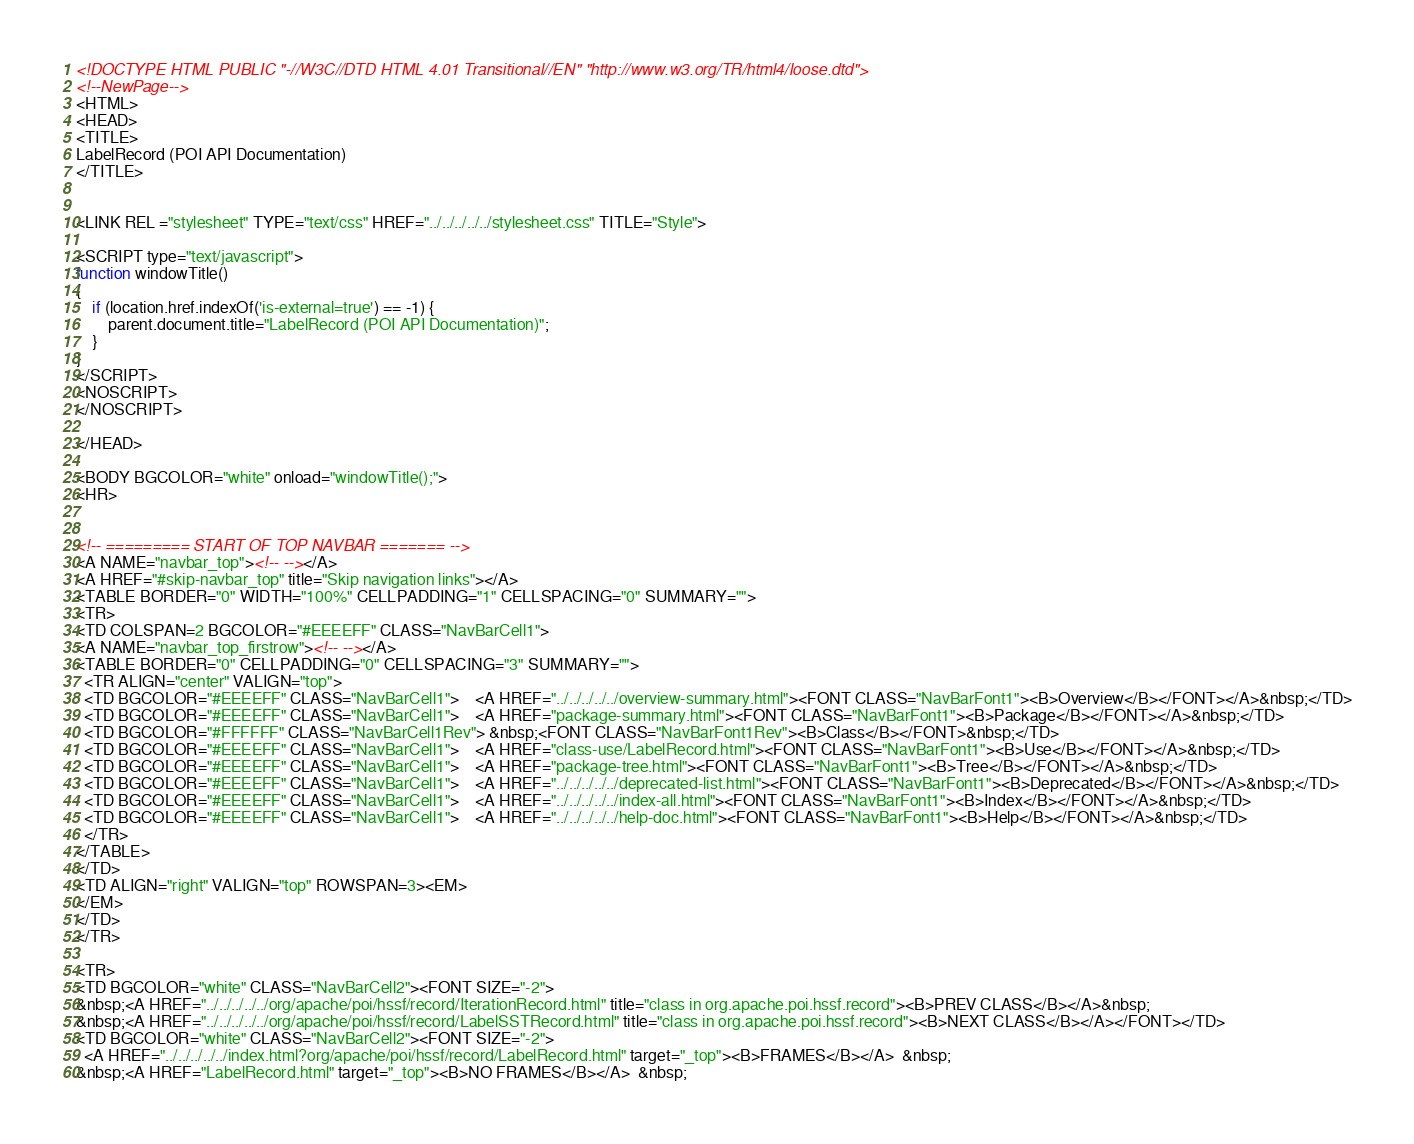<code> <loc_0><loc_0><loc_500><loc_500><_HTML_><!DOCTYPE HTML PUBLIC "-//W3C//DTD HTML 4.01 Transitional//EN" "http://www.w3.org/TR/html4/loose.dtd">
<!--NewPage-->
<HTML>
<HEAD>
<TITLE>
LabelRecord (POI API Documentation)
</TITLE>


<LINK REL ="stylesheet" TYPE="text/css" HREF="../../../../../stylesheet.css" TITLE="Style">

<SCRIPT type="text/javascript">
function windowTitle()
{
    if (location.href.indexOf('is-external=true') == -1) {
        parent.document.title="LabelRecord (POI API Documentation)";
    }
}
</SCRIPT>
<NOSCRIPT>
</NOSCRIPT>

</HEAD>

<BODY BGCOLOR="white" onload="windowTitle();">
<HR>


<!-- ========= START OF TOP NAVBAR ======= -->
<A NAME="navbar_top"><!-- --></A>
<A HREF="#skip-navbar_top" title="Skip navigation links"></A>
<TABLE BORDER="0" WIDTH="100%" CELLPADDING="1" CELLSPACING="0" SUMMARY="">
<TR>
<TD COLSPAN=2 BGCOLOR="#EEEEFF" CLASS="NavBarCell1">
<A NAME="navbar_top_firstrow"><!-- --></A>
<TABLE BORDER="0" CELLPADDING="0" CELLSPACING="3" SUMMARY="">
  <TR ALIGN="center" VALIGN="top">
  <TD BGCOLOR="#EEEEFF" CLASS="NavBarCell1">    <A HREF="../../../../../overview-summary.html"><FONT CLASS="NavBarFont1"><B>Overview</B></FONT></A>&nbsp;</TD>
  <TD BGCOLOR="#EEEEFF" CLASS="NavBarCell1">    <A HREF="package-summary.html"><FONT CLASS="NavBarFont1"><B>Package</B></FONT></A>&nbsp;</TD>
  <TD BGCOLOR="#FFFFFF" CLASS="NavBarCell1Rev"> &nbsp;<FONT CLASS="NavBarFont1Rev"><B>Class</B></FONT>&nbsp;</TD>
  <TD BGCOLOR="#EEEEFF" CLASS="NavBarCell1">    <A HREF="class-use/LabelRecord.html"><FONT CLASS="NavBarFont1"><B>Use</B></FONT></A>&nbsp;</TD>
  <TD BGCOLOR="#EEEEFF" CLASS="NavBarCell1">    <A HREF="package-tree.html"><FONT CLASS="NavBarFont1"><B>Tree</B></FONT></A>&nbsp;</TD>
  <TD BGCOLOR="#EEEEFF" CLASS="NavBarCell1">    <A HREF="../../../../../deprecated-list.html"><FONT CLASS="NavBarFont1"><B>Deprecated</B></FONT></A>&nbsp;</TD>
  <TD BGCOLOR="#EEEEFF" CLASS="NavBarCell1">    <A HREF="../../../../../index-all.html"><FONT CLASS="NavBarFont1"><B>Index</B></FONT></A>&nbsp;</TD>
  <TD BGCOLOR="#EEEEFF" CLASS="NavBarCell1">    <A HREF="../../../../../help-doc.html"><FONT CLASS="NavBarFont1"><B>Help</B></FONT></A>&nbsp;</TD>
  </TR>
</TABLE>
</TD>
<TD ALIGN="right" VALIGN="top" ROWSPAN=3><EM>
</EM>
</TD>
</TR>

<TR>
<TD BGCOLOR="white" CLASS="NavBarCell2"><FONT SIZE="-2">
&nbsp;<A HREF="../../../../../org/apache/poi/hssf/record/IterationRecord.html" title="class in org.apache.poi.hssf.record"><B>PREV CLASS</B></A>&nbsp;
&nbsp;<A HREF="../../../../../org/apache/poi/hssf/record/LabelSSTRecord.html" title="class in org.apache.poi.hssf.record"><B>NEXT CLASS</B></A></FONT></TD>
<TD BGCOLOR="white" CLASS="NavBarCell2"><FONT SIZE="-2">
  <A HREF="../../../../../index.html?org/apache/poi/hssf/record/LabelRecord.html" target="_top"><B>FRAMES</B></A>  &nbsp;
&nbsp;<A HREF="LabelRecord.html" target="_top"><B>NO FRAMES</B></A>  &nbsp;</code> 